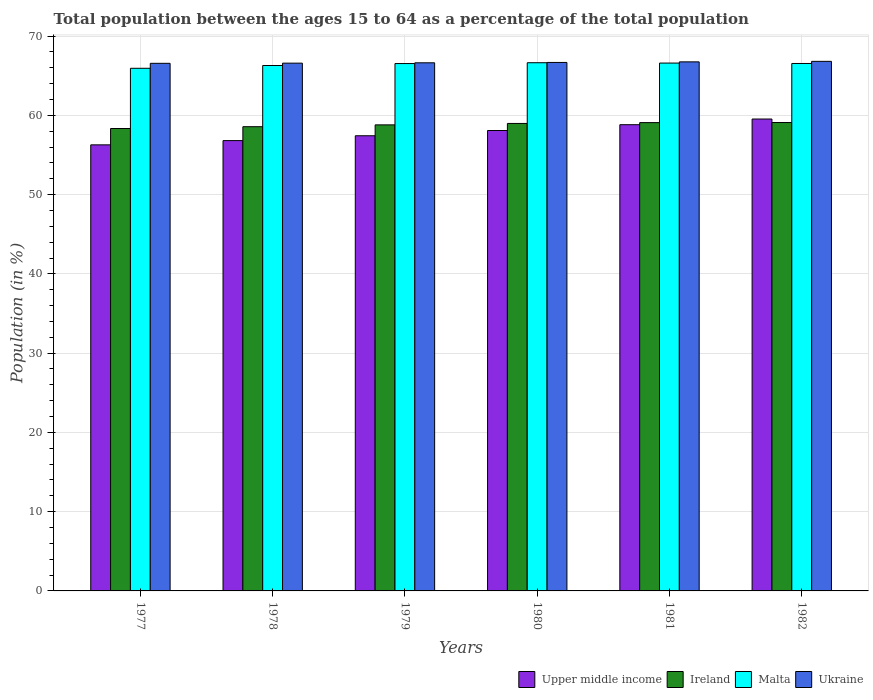What is the percentage of the population ages 15 to 64 in Malta in 1980?
Provide a short and direct response. 66.64. Across all years, what is the maximum percentage of the population ages 15 to 64 in Malta?
Your answer should be very brief. 66.64. Across all years, what is the minimum percentage of the population ages 15 to 64 in Ukraine?
Offer a terse response. 66.57. In which year was the percentage of the population ages 15 to 64 in Ireland maximum?
Offer a very short reply. 1982. In which year was the percentage of the population ages 15 to 64 in Upper middle income minimum?
Provide a short and direct response. 1977. What is the total percentage of the population ages 15 to 64 in Malta in the graph?
Your answer should be very brief. 398.56. What is the difference between the percentage of the population ages 15 to 64 in Malta in 1979 and that in 1982?
Make the answer very short. -0.01. What is the difference between the percentage of the population ages 15 to 64 in Malta in 1977 and the percentage of the population ages 15 to 64 in Upper middle income in 1978?
Offer a terse response. 9.12. What is the average percentage of the population ages 15 to 64 in Ireland per year?
Provide a succinct answer. 58.81. In the year 1981, what is the difference between the percentage of the population ages 15 to 64 in Malta and percentage of the population ages 15 to 64 in Ireland?
Provide a succinct answer. 7.51. In how many years, is the percentage of the population ages 15 to 64 in Ireland greater than 46?
Provide a short and direct response. 6. What is the ratio of the percentage of the population ages 15 to 64 in Ukraine in 1977 to that in 1979?
Keep it short and to the point. 1. Is the difference between the percentage of the population ages 15 to 64 in Malta in 1980 and 1981 greater than the difference between the percentage of the population ages 15 to 64 in Ireland in 1980 and 1981?
Give a very brief answer. Yes. What is the difference between the highest and the second highest percentage of the population ages 15 to 64 in Upper middle income?
Provide a succinct answer. 0.71. What is the difference between the highest and the lowest percentage of the population ages 15 to 64 in Upper middle income?
Offer a terse response. 3.26. Is the sum of the percentage of the population ages 15 to 64 in Upper middle income in 1978 and 1979 greater than the maximum percentage of the population ages 15 to 64 in Malta across all years?
Ensure brevity in your answer.  Yes. What does the 3rd bar from the left in 1979 represents?
Your response must be concise. Malta. What does the 4th bar from the right in 1982 represents?
Your response must be concise. Upper middle income. How many bars are there?
Your answer should be very brief. 24. How many years are there in the graph?
Ensure brevity in your answer.  6. What is the difference between two consecutive major ticks on the Y-axis?
Keep it short and to the point. 10. Are the values on the major ticks of Y-axis written in scientific E-notation?
Make the answer very short. No. Does the graph contain any zero values?
Keep it short and to the point. No. Where does the legend appear in the graph?
Your response must be concise. Bottom right. How are the legend labels stacked?
Ensure brevity in your answer.  Horizontal. What is the title of the graph?
Offer a very short reply. Total population between the ages 15 to 64 as a percentage of the total population. What is the label or title of the X-axis?
Your answer should be very brief. Years. What is the label or title of the Y-axis?
Your answer should be very brief. Population (in %). What is the Population (in %) in Upper middle income in 1977?
Offer a terse response. 56.28. What is the Population (in %) in Ireland in 1977?
Provide a short and direct response. 58.34. What is the Population (in %) of Malta in 1977?
Your answer should be compact. 65.94. What is the Population (in %) of Ukraine in 1977?
Offer a terse response. 66.57. What is the Population (in %) of Upper middle income in 1978?
Provide a short and direct response. 56.82. What is the Population (in %) in Ireland in 1978?
Make the answer very short. 58.57. What is the Population (in %) in Malta in 1978?
Your answer should be compact. 66.29. What is the Population (in %) of Ukraine in 1978?
Make the answer very short. 66.59. What is the Population (in %) of Upper middle income in 1979?
Give a very brief answer. 57.43. What is the Population (in %) of Ireland in 1979?
Your answer should be very brief. 58.8. What is the Population (in %) in Malta in 1979?
Give a very brief answer. 66.54. What is the Population (in %) of Ukraine in 1979?
Ensure brevity in your answer.  66.63. What is the Population (in %) in Upper middle income in 1980?
Give a very brief answer. 58.09. What is the Population (in %) in Ireland in 1980?
Your answer should be compact. 58.98. What is the Population (in %) of Malta in 1980?
Give a very brief answer. 66.64. What is the Population (in %) in Ukraine in 1980?
Give a very brief answer. 66.68. What is the Population (in %) of Upper middle income in 1981?
Give a very brief answer. 58.82. What is the Population (in %) of Ireland in 1981?
Offer a very short reply. 59.09. What is the Population (in %) in Malta in 1981?
Ensure brevity in your answer.  66.6. What is the Population (in %) in Ukraine in 1981?
Your response must be concise. 66.75. What is the Population (in %) in Upper middle income in 1982?
Your answer should be compact. 59.54. What is the Population (in %) of Ireland in 1982?
Provide a succinct answer. 59.1. What is the Population (in %) of Malta in 1982?
Offer a very short reply. 66.55. What is the Population (in %) in Ukraine in 1982?
Ensure brevity in your answer.  66.82. Across all years, what is the maximum Population (in %) in Upper middle income?
Give a very brief answer. 59.54. Across all years, what is the maximum Population (in %) in Ireland?
Provide a short and direct response. 59.1. Across all years, what is the maximum Population (in %) of Malta?
Offer a very short reply. 66.64. Across all years, what is the maximum Population (in %) of Ukraine?
Ensure brevity in your answer.  66.82. Across all years, what is the minimum Population (in %) in Upper middle income?
Provide a succinct answer. 56.28. Across all years, what is the minimum Population (in %) of Ireland?
Ensure brevity in your answer.  58.34. Across all years, what is the minimum Population (in %) in Malta?
Your response must be concise. 65.94. Across all years, what is the minimum Population (in %) of Ukraine?
Give a very brief answer. 66.57. What is the total Population (in %) of Upper middle income in the graph?
Make the answer very short. 346.98. What is the total Population (in %) in Ireland in the graph?
Give a very brief answer. 352.88. What is the total Population (in %) of Malta in the graph?
Offer a terse response. 398.56. What is the total Population (in %) in Ukraine in the graph?
Provide a short and direct response. 400.03. What is the difference between the Population (in %) of Upper middle income in 1977 and that in 1978?
Provide a short and direct response. -0.54. What is the difference between the Population (in %) in Ireland in 1977 and that in 1978?
Ensure brevity in your answer.  -0.23. What is the difference between the Population (in %) in Malta in 1977 and that in 1978?
Offer a very short reply. -0.35. What is the difference between the Population (in %) in Ukraine in 1977 and that in 1978?
Provide a short and direct response. -0.02. What is the difference between the Population (in %) in Upper middle income in 1977 and that in 1979?
Your answer should be compact. -1.15. What is the difference between the Population (in %) in Ireland in 1977 and that in 1979?
Offer a very short reply. -0.46. What is the difference between the Population (in %) of Malta in 1977 and that in 1979?
Your answer should be compact. -0.6. What is the difference between the Population (in %) of Ukraine in 1977 and that in 1979?
Provide a succinct answer. -0.06. What is the difference between the Population (in %) of Upper middle income in 1977 and that in 1980?
Give a very brief answer. -1.81. What is the difference between the Population (in %) in Ireland in 1977 and that in 1980?
Your answer should be compact. -0.64. What is the difference between the Population (in %) of Malta in 1977 and that in 1980?
Ensure brevity in your answer.  -0.7. What is the difference between the Population (in %) in Ukraine in 1977 and that in 1980?
Ensure brevity in your answer.  -0.11. What is the difference between the Population (in %) in Upper middle income in 1977 and that in 1981?
Make the answer very short. -2.54. What is the difference between the Population (in %) in Ireland in 1977 and that in 1981?
Provide a succinct answer. -0.74. What is the difference between the Population (in %) of Malta in 1977 and that in 1981?
Keep it short and to the point. -0.66. What is the difference between the Population (in %) of Ukraine in 1977 and that in 1981?
Provide a short and direct response. -0.18. What is the difference between the Population (in %) of Upper middle income in 1977 and that in 1982?
Give a very brief answer. -3.26. What is the difference between the Population (in %) of Ireland in 1977 and that in 1982?
Keep it short and to the point. -0.76. What is the difference between the Population (in %) of Malta in 1977 and that in 1982?
Your answer should be very brief. -0.61. What is the difference between the Population (in %) in Ukraine in 1977 and that in 1982?
Make the answer very short. -0.25. What is the difference between the Population (in %) in Upper middle income in 1978 and that in 1979?
Give a very brief answer. -0.61. What is the difference between the Population (in %) of Ireland in 1978 and that in 1979?
Offer a terse response. -0.23. What is the difference between the Population (in %) of Malta in 1978 and that in 1979?
Keep it short and to the point. -0.25. What is the difference between the Population (in %) of Ukraine in 1978 and that in 1979?
Offer a terse response. -0.04. What is the difference between the Population (in %) of Upper middle income in 1978 and that in 1980?
Your response must be concise. -1.27. What is the difference between the Population (in %) of Ireland in 1978 and that in 1980?
Your answer should be compact. -0.41. What is the difference between the Population (in %) of Malta in 1978 and that in 1980?
Your response must be concise. -0.35. What is the difference between the Population (in %) in Ukraine in 1978 and that in 1980?
Provide a short and direct response. -0.09. What is the difference between the Population (in %) of Upper middle income in 1978 and that in 1981?
Your answer should be very brief. -2.01. What is the difference between the Population (in %) in Ireland in 1978 and that in 1981?
Make the answer very short. -0.51. What is the difference between the Population (in %) in Malta in 1978 and that in 1981?
Offer a very short reply. -0.31. What is the difference between the Population (in %) of Ukraine in 1978 and that in 1981?
Ensure brevity in your answer.  -0.16. What is the difference between the Population (in %) in Upper middle income in 1978 and that in 1982?
Make the answer very short. -2.72. What is the difference between the Population (in %) in Ireland in 1978 and that in 1982?
Offer a very short reply. -0.53. What is the difference between the Population (in %) of Malta in 1978 and that in 1982?
Offer a very short reply. -0.26. What is the difference between the Population (in %) in Ukraine in 1978 and that in 1982?
Provide a short and direct response. -0.23. What is the difference between the Population (in %) of Upper middle income in 1979 and that in 1980?
Make the answer very short. -0.66. What is the difference between the Population (in %) in Ireland in 1979 and that in 1980?
Keep it short and to the point. -0.18. What is the difference between the Population (in %) in Malta in 1979 and that in 1980?
Keep it short and to the point. -0.1. What is the difference between the Population (in %) of Ukraine in 1979 and that in 1980?
Your answer should be compact. -0.04. What is the difference between the Population (in %) in Upper middle income in 1979 and that in 1981?
Give a very brief answer. -1.4. What is the difference between the Population (in %) in Ireland in 1979 and that in 1981?
Keep it short and to the point. -0.28. What is the difference between the Population (in %) of Malta in 1979 and that in 1981?
Make the answer very short. -0.06. What is the difference between the Population (in %) of Ukraine in 1979 and that in 1981?
Your answer should be very brief. -0.12. What is the difference between the Population (in %) of Upper middle income in 1979 and that in 1982?
Your answer should be very brief. -2.11. What is the difference between the Population (in %) of Ireland in 1979 and that in 1982?
Keep it short and to the point. -0.29. What is the difference between the Population (in %) in Malta in 1979 and that in 1982?
Offer a very short reply. -0.01. What is the difference between the Population (in %) of Ukraine in 1979 and that in 1982?
Make the answer very short. -0.18. What is the difference between the Population (in %) in Upper middle income in 1980 and that in 1981?
Make the answer very short. -0.73. What is the difference between the Population (in %) in Ireland in 1980 and that in 1981?
Your response must be concise. -0.1. What is the difference between the Population (in %) of Malta in 1980 and that in 1981?
Provide a short and direct response. 0.04. What is the difference between the Population (in %) in Ukraine in 1980 and that in 1981?
Make the answer very short. -0.07. What is the difference between the Population (in %) in Upper middle income in 1980 and that in 1982?
Your answer should be very brief. -1.45. What is the difference between the Population (in %) in Ireland in 1980 and that in 1982?
Provide a succinct answer. -0.11. What is the difference between the Population (in %) of Malta in 1980 and that in 1982?
Give a very brief answer. 0.1. What is the difference between the Population (in %) in Ukraine in 1980 and that in 1982?
Keep it short and to the point. -0.14. What is the difference between the Population (in %) of Upper middle income in 1981 and that in 1982?
Make the answer very short. -0.71. What is the difference between the Population (in %) of Ireland in 1981 and that in 1982?
Offer a terse response. -0.01. What is the difference between the Population (in %) in Malta in 1981 and that in 1982?
Keep it short and to the point. 0.05. What is the difference between the Population (in %) of Ukraine in 1981 and that in 1982?
Your answer should be compact. -0.06. What is the difference between the Population (in %) in Upper middle income in 1977 and the Population (in %) in Ireland in 1978?
Offer a terse response. -2.29. What is the difference between the Population (in %) in Upper middle income in 1977 and the Population (in %) in Malta in 1978?
Make the answer very short. -10.01. What is the difference between the Population (in %) of Upper middle income in 1977 and the Population (in %) of Ukraine in 1978?
Your response must be concise. -10.31. What is the difference between the Population (in %) in Ireland in 1977 and the Population (in %) in Malta in 1978?
Give a very brief answer. -7.95. What is the difference between the Population (in %) in Ireland in 1977 and the Population (in %) in Ukraine in 1978?
Offer a very short reply. -8.25. What is the difference between the Population (in %) of Malta in 1977 and the Population (in %) of Ukraine in 1978?
Make the answer very short. -0.65. What is the difference between the Population (in %) of Upper middle income in 1977 and the Population (in %) of Ireland in 1979?
Ensure brevity in your answer.  -2.52. What is the difference between the Population (in %) of Upper middle income in 1977 and the Population (in %) of Malta in 1979?
Provide a short and direct response. -10.26. What is the difference between the Population (in %) in Upper middle income in 1977 and the Population (in %) in Ukraine in 1979?
Offer a terse response. -10.35. What is the difference between the Population (in %) in Ireland in 1977 and the Population (in %) in Malta in 1979?
Provide a succinct answer. -8.2. What is the difference between the Population (in %) in Ireland in 1977 and the Population (in %) in Ukraine in 1979?
Ensure brevity in your answer.  -8.29. What is the difference between the Population (in %) in Malta in 1977 and the Population (in %) in Ukraine in 1979?
Your answer should be compact. -0.69. What is the difference between the Population (in %) of Upper middle income in 1977 and the Population (in %) of Ireland in 1980?
Provide a short and direct response. -2.7. What is the difference between the Population (in %) of Upper middle income in 1977 and the Population (in %) of Malta in 1980?
Provide a short and direct response. -10.36. What is the difference between the Population (in %) in Upper middle income in 1977 and the Population (in %) in Ukraine in 1980?
Offer a very short reply. -10.4. What is the difference between the Population (in %) in Ireland in 1977 and the Population (in %) in Malta in 1980?
Ensure brevity in your answer.  -8.3. What is the difference between the Population (in %) in Ireland in 1977 and the Population (in %) in Ukraine in 1980?
Your answer should be compact. -8.33. What is the difference between the Population (in %) in Malta in 1977 and the Population (in %) in Ukraine in 1980?
Provide a succinct answer. -0.74. What is the difference between the Population (in %) in Upper middle income in 1977 and the Population (in %) in Ireland in 1981?
Keep it short and to the point. -2.8. What is the difference between the Population (in %) in Upper middle income in 1977 and the Population (in %) in Malta in 1981?
Keep it short and to the point. -10.32. What is the difference between the Population (in %) in Upper middle income in 1977 and the Population (in %) in Ukraine in 1981?
Ensure brevity in your answer.  -10.47. What is the difference between the Population (in %) in Ireland in 1977 and the Population (in %) in Malta in 1981?
Provide a succinct answer. -8.26. What is the difference between the Population (in %) of Ireland in 1977 and the Population (in %) of Ukraine in 1981?
Your response must be concise. -8.41. What is the difference between the Population (in %) in Malta in 1977 and the Population (in %) in Ukraine in 1981?
Provide a short and direct response. -0.81. What is the difference between the Population (in %) in Upper middle income in 1977 and the Population (in %) in Ireland in 1982?
Ensure brevity in your answer.  -2.82. What is the difference between the Population (in %) in Upper middle income in 1977 and the Population (in %) in Malta in 1982?
Your answer should be compact. -10.27. What is the difference between the Population (in %) in Upper middle income in 1977 and the Population (in %) in Ukraine in 1982?
Your answer should be compact. -10.53. What is the difference between the Population (in %) in Ireland in 1977 and the Population (in %) in Malta in 1982?
Make the answer very short. -8.21. What is the difference between the Population (in %) in Ireland in 1977 and the Population (in %) in Ukraine in 1982?
Your response must be concise. -8.47. What is the difference between the Population (in %) of Malta in 1977 and the Population (in %) of Ukraine in 1982?
Make the answer very short. -0.88. What is the difference between the Population (in %) in Upper middle income in 1978 and the Population (in %) in Ireland in 1979?
Your answer should be compact. -1.99. What is the difference between the Population (in %) in Upper middle income in 1978 and the Population (in %) in Malta in 1979?
Provide a succinct answer. -9.72. What is the difference between the Population (in %) in Upper middle income in 1978 and the Population (in %) in Ukraine in 1979?
Provide a short and direct response. -9.82. What is the difference between the Population (in %) in Ireland in 1978 and the Population (in %) in Malta in 1979?
Offer a terse response. -7.97. What is the difference between the Population (in %) in Ireland in 1978 and the Population (in %) in Ukraine in 1979?
Ensure brevity in your answer.  -8.06. What is the difference between the Population (in %) of Malta in 1978 and the Population (in %) of Ukraine in 1979?
Your answer should be compact. -0.34. What is the difference between the Population (in %) of Upper middle income in 1978 and the Population (in %) of Ireland in 1980?
Your response must be concise. -2.16. What is the difference between the Population (in %) of Upper middle income in 1978 and the Population (in %) of Malta in 1980?
Give a very brief answer. -9.83. What is the difference between the Population (in %) of Upper middle income in 1978 and the Population (in %) of Ukraine in 1980?
Your response must be concise. -9.86. What is the difference between the Population (in %) in Ireland in 1978 and the Population (in %) in Malta in 1980?
Your answer should be compact. -8.07. What is the difference between the Population (in %) of Ireland in 1978 and the Population (in %) of Ukraine in 1980?
Ensure brevity in your answer.  -8.11. What is the difference between the Population (in %) of Malta in 1978 and the Population (in %) of Ukraine in 1980?
Ensure brevity in your answer.  -0.39. What is the difference between the Population (in %) in Upper middle income in 1978 and the Population (in %) in Ireland in 1981?
Your answer should be very brief. -2.27. What is the difference between the Population (in %) of Upper middle income in 1978 and the Population (in %) of Malta in 1981?
Give a very brief answer. -9.78. What is the difference between the Population (in %) in Upper middle income in 1978 and the Population (in %) in Ukraine in 1981?
Give a very brief answer. -9.93. What is the difference between the Population (in %) in Ireland in 1978 and the Population (in %) in Malta in 1981?
Offer a very short reply. -8.03. What is the difference between the Population (in %) in Ireland in 1978 and the Population (in %) in Ukraine in 1981?
Offer a very short reply. -8.18. What is the difference between the Population (in %) in Malta in 1978 and the Population (in %) in Ukraine in 1981?
Offer a very short reply. -0.46. What is the difference between the Population (in %) in Upper middle income in 1978 and the Population (in %) in Ireland in 1982?
Your answer should be compact. -2.28. What is the difference between the Population (in %) of Upper middle income in 1978 and the Population (in %) of Malta in 1982?
Your answer should be very brief. -9.73. What is the difference between the Population (in %) of Upper middle income in 1978 and the Population (in %) of Ukraine in 1982?
Provide a succinct answer. -10. What is the difference between the Population (in %) in Ireland in 1978 and the Population (in %) in Malta in 1982?
Ensure brevity in your answer.  -7.98. What is the difference between the Population (in %) of Ireland in 1978 and the Population (in %) of Ukraine in 1982?
Your answer should be very brief. -8.24. What is the difference between the Population (in %) in Malta in 1978 and the Population (in %) in Ukraine in 1982?
Offer a terse response. -0.52. What is the difference between the Population (in %) of Upper middle income in 1979 and the Population (in %) of Ireland in 1980?
Make the answer very short. -1.55. What is the difference between the Population (in %) of Upper middle income in 1979 and the Population (in %) of Malta in 1980?
Ensure brevity in your answer.  -9.21. What is the difference between the Population (in %) of Upper middle income in 1979 and the Population (in %) of Ukraine in 1980?
Your answer should be compact. -9.25. What is the difference between the Population (in %) of Ireland in 1979 and the Population (in %) of Malta in 1980?
Your response must be concise. -7.84. What is the difference between the Population (in %) of Ireland in 1979 and the Population (in %) of Ukraine in 1980?
Provide a succinct answer. -7.87. What is the difference between the Population (in %) of Malta in 1979 and the Population (in %) of Ukraine in 1980?
Give a very brief answer. -0.14. What is the difference between the Population (in %) of Upper middle income in 1979 and the Population (in %) of Ireland in 1981?
Make the answer very short. -1.66. What is the difference between the Population (in %) in Upper middle income in 1979 and the Population (in %) in Malta in 1981?
Keep it short and to the point. -9.17. What is the difference between the Population (in %) in Upper middle income in 1979 and the Population (in %) in Ukraine in 1981?
Give a very brief answer. -9.32. What is the difference between the Population (in %) in Ireland in 1979 and the Population (in %) in Malta in 1981?
Your response must be concise. -7.8. What is the difference between the Population (in %) in Ireland in 1979 and the Population (in %) in Ukraine in 1981?
Provide a short and direct response. -7.95. What is the difference between the Population (in %) of Malta in 1979 and the Population (in %) of Ukraine in 1981?
Your answer should be compact. -0.21. What is the difference between the Population (in %) of Upper middle income in 1979 and the Population (in %) of Ireland in 1982?
Ensure brevity in your answer.  -1.67. What is the difference between the Population (in %) in Upper middle income in 1979 and the Population (in %) in Malta in 1982?
Your response must be concise. -9.12. What is the difference between the Population (in %) of Upper middle income in 1979 and the Population (in %) of Ukraine in 1982?
Provide a succinct answer. -9.39. What is the difference between the Population (in %) of Ireland in 1979 and the Population (in %) of Malta in 1982?
Ensure brevity in your answer.  -7.75. What is the difference between the Population (in %) in Ireland in 1979 and the Population (in %) in Ukraine in 1982?
Your answer should be compact. -8.01. What is the difference between the Population (in %) of Malta in 1979 and the Population (in %) of Ukraine in 1982?
Provide a short and direct response. -0.28. What is the difference between the Population (in %) in Upper middle income in 1980 and the Population (in %) in Ireland in 1981?
Your response must be concise. -0.99. What is the difference between the Population (in %) in Upper middle income in 1980 and the Population (in %) in Malta in 1981?
Your response must be concise. -8.51. What is the difference between the Population (in %) of Upper middle income in 1980 and the Population (in %) of Ukraine in 1981?
Your answer should be compact. -8.66. What is the difference between the Population (in %) of Ireland in 1980 and the Population (in %) of Malta in 1981?
Ensure brevity in your answer.  -7.62. What is the difference between the Population (in %) in Ireland in 1980 and the Population (in %) in Ukraine in 1981?
Keep it short and to the point. -7.77. What is the difference between the Population (in %) of Malta in 1980 and the Population (in %) of Ukraine in 1981?
Give a very brief answer. -0.11. What is the difference between the Population (in %) in Upper middle income in 1980 and the Population (in %) in Ireland in 1982?
Give a very brief answer. -1.01. What is the difference between the Population (in %) in Upper middle income in 1980 and the Population (in %) in Malta in 1982?
Your answer should be compact. -8.46. What is the difference between the Population (in %) in Upper middle income in 1980 and the Population (in %) in Ukraine in 1982?
Offer a very short reply. -8.72. What is the difference between the Population (in %) in Ireland in 1980 and the Population (in %) in Malta in 1982?
Ensure brevity in your answer.  -7.57. What is the difference between the Population (in %) in Ireland in 1980 and the Population (in %) in Ukraine in 1982?
Give a very brief answer. -7.83. What is the difference between the Population (in %) of Malta in 1980 and the Population (in %) of Ukraine in 1982?
Your response must be concise. -0.17. What is the difference between the Population (in %) of Upper middle income in 1981 and the Population (in %) of Ireland in 1982?
Your answer should be very brief. -0.27. What is the difference between the Population (in %) in Upper middle income in 1981 and the Population (in %) in Malta in 1982?
Offer a terse response. -7.72. What is the difference between the Population (in %) of Upper middle income in 1981 and the Population (in %) of Ukraine in 1982?
Keep it short and to the point. -7.99. What is the difference between the Population (in %) in Ireland in 1981 and the Population (in %) in Malta in 1982?
Your answer should be very brief. -7.46. What is the difference between the Population (in %) of Ireland in 1981 and the Population (in %) of Ukraine in 1982?
Ensure brevity in your answer.  -7.73. What is the difference between the Population (in %) in Malta in 1981 and the Population (in %) in Ukraine in 1982?
Give a very brief answer. -0.22. What is the average Population (in %) of Upper middle income per year?
Offer a very short reply. 57.83. What is the average Population (in %) in Ireland per year?
Provide a succinct answer. 58.81. What is the average Population (in %) of Malta per year?
Give a very brief answer. 66.43. What is the average Population (in %) of Ukraine per year?
Ensure brevity in your answer.  66.67. In the year 1977, what is the difference between the Population (in %) of Upper middle income and Population (in %) of Ireland?
Offer a very short reply. -2.06. In the year 1977, what is the difference between the Population (in %) of Upper middle income and Population (in %) of Malta?
Offer a very short reply. -9.66. In the year 1977, what is the difference between the Population (in %) in Upper middle income and Population (in %) in Ukraine?
Offer a terse response. -10.29. In the year 1977, what is the difference between the Population (in %) of Ireland and Population (in %) of Malta?
Your answer should be compact. -7.6. In the year 1977, what is the difference between the Population (in %) of Ireland and Population (in %) of Ukraine?
Offer a very short reply. -8.23. In the year 1977, what is the difference between the Population (in %) of Malta and Population (in %) of Ukraine?
Your answer should be very brief. -0.63. In the year 1978, what is the difference between the Population (in %) of Upper middle income and Population (in %) of Ireland?
Your answer should be compact. -1.75. In the year 1978, what is the difference between the Population (in %) of Upper middle income and Population (in %) of Malta?
Provide a short and direct response. -9.47. In the year 1978, what is the difference between the Population (in %) of Upper middle income and Population (in %) of Ukraine?
Make the answer very short. -9.77. In the year 1978, what is the difference between the Population (in %) in Ireland and Population (in %) in Malta?
Offer a terse response. -7.72. In the year 1978, what is the difference between the Population (in %) of Ireland and Population (in %) of Ukraine?
Keep it short and to the point. -8.02. In the year 1978, what is the difference between the Population (in %) of Malta and Population (in %) of Ukraine?
Offer a terse response. -0.3. In the year 1979, what is the difference between the Population (in %) in Upper middle income and Population (in %) in Ireland?
Make the answer very short. -1.37. In the year 1979, what is the difference between the Population (in %) in Upper middle income and Population (in %) in Malta?
Your answer should be compact. -9.11. In the year 1979, what is the difference between the Population (in %) in Upper middle income and Population (in %) in Ukraine?
Give a very brief answer. -9.2. In the year 1979, what is the difference between the Population (in %) in Ireland and Population (in %) in Malta?
Give a very brief answer. -7.74. In the year 1979, what is the difference between the Population (in %) in Ireland and Population (in %) in Ukraine?
Make the answer very short. -7.83. In the year 1979, what is the difference between the Population (in %) of Malta and Population (in %) of Ukraine?
Provide a short and direct response. -0.09. In the year 1980, what is the difference between the Population (in %) of Upper middle income and Population (in %) of Ireland?
Offer a terse response. -0.89. In the year 1980, what is the difference between the Population (in %) of Upper middle income and Population (in %) of Malta?
Keep it short and to the point. -8.55. In the year 1980, what is the difference between the Population (in %) of Upper middle income and Population (in %) of Ukraine?
Ensure brevity in your answer.  -8.59. In the year 1980, what is the difference between the Population (in %) in Ireland and Population (in %) in Malta?
Offer a terse response. -7.66. In the year 1980, what is the difference between the Population (in %) of Ireland and Population (in %) of Ukraine?
Offer a very short reply. -7.69. In the year 1980, what is the difference between the Population (in %) of Malta and Population (in %) of Ukraine?
Keep it short and to the point. -0.03. In the year 1981, what is the difference between the Population (in %) in Upper middle income and Population (in %) in Ireland?
Keep it short and to the point. -0.26. In the year 1981, what is the difference between the Population (in %) in Upper middle income and Population (in %) in Malta?
Ensure brevity in your answer.  -7.77. In the year 1981, what is the difference between the Population (in %) of Upper middle income and Population (in %) of Ukraine?
Offer a very short reply. -7.93. In the year 1981, what is the difference between the Population (in %) of Ireland and Population (in %) of Malta?
Your answer should be very brief. -7.51. In the year 1981, what is the difference between the Population (in %) in Ireland and Population (in %) in Ukraine?
Offer a very short reply. -7.67. In the year 1981, what is the difference between the Population (in %) in Malta and Population (in %) in Ukraine?
Make the answer very short. -0.15. In the year 1982, what is the difference between the Population (in %) of Upper middle income and Population (in %) of Ireland?
Give a very brief answer. 0.44. In the year 1982, what is the difference between the Population (in %) of Upper middle income and Population (in %) of Malta?
Offer a very short reply. -7.01. In the year 1982, what is the difference between the Population (in %) of Upper middle income and Population (in %) of Ukraine?
Keep it short and to the point. -7.28. In the year 1982, what is the difference between the Population (in %) of Ireland and Population (in %) of Malta?
Keep it short and to the point. -7.45. In the year 1982, what is the difference between the Population (in %) of Ireland and Population (in %) of Ukraine?
Offer a terse response. -7.72. In the year 1982, what is the difference between the Population (in %) in Malta and Population (in %) in Ukraine?
Your answer should be very brief. -0.27. What is the ratio of the Population (in %) in Upper middle income in 1977 to that in 1978?
Keep it short and to the point. 0.99. What is the ratio of the Population (in %) in Ireland in 1977 to that in 1978?
Your answer should be very brief. 1. What is the ratio of the Population (in %) in Ukraine in 1977 to that in 1978?
Offer a terse response. 1. What is the ratio of the Population (in %) of Upper middle income in 1977 to that in 1979?
Keep it short and to the point. 0.98. What is the ratio of the Population (in %) of Ireland in 1977 to that in 1979?
Provide a succinct answer. 0.99. What is the ratio of the Population (in %) in Upper middle income in 1977 to that in 1980?
Make the answer very short. 0.97. What is the ratio of the Population (in %) of Ukraine in 1977 to that in 1980?
Your answer should be very brief. 1. What is the ratio of the Population (in %) in Upper middle income in 1977 to that in 1981?
Offer a very short reply. 0.96. What is the ratio of the Population (in %) in Ireland in 1977 to that in 1981?
Provide a succinct answer. 0.99. What is the ratio of the Population (in %) of Malta in 1977 to that in 1981?
Ensure brevity in your answer.  0.99. What is the ratio of the Population (in %) in Upper middle income in 1977 to that in 1982?
Offer a very short reply. 0.95. What is the ratio of the Population (in %) in Ireland in 1977 to that in 1982?
Your answer should be very brief. 0.99. What is the ratio of the Population (in %) in Malta in 1977 to that in 1982?
Keep it short and to the point. 0.99. What is the ratio of the Population (in %) of Upper middle income in 1978 to that in 1979?
Keep it short and to the point. 0.99. What is the ratio of the Population (in %) of Ireland in 1978 to that in 1979?
Make the answer very short. 1. What is the ratio of the Population (in %) of Ukraine in 1978 to that in 1979?
Your response must be concise. 1. What is the ratio of the Population (in %) in Upper middle income in 1978 to that in 1980?
Provide a short and direct response. 0.98. What is the ratio of the Population (in %) in Upper middle income in 1978 to that in 1981?
Make the answer very short. 0.97. What is the ratio of the Population (in %) of Malta in 1978 to that in 1981?
Keep it short and to the point. 1. What is the ratio of the Population (in %) of Upper middle income in 1978 to that in 1982?
Keep it short and to the point. 0.95. What is the ratio of the Population (in %) in Ireland in 1978 to that in 1982?
Give a very brief answer. 0.99. What is the ratio of the Population (in %) in Malta in 1978 to that in 1982?
Ensure brevity in your answer.  1. What is the ratio of the Population (in %) in Upper middle income in 1979 to that in 1980?
Offer a very short reply. 0.99. What is the ratio of the Population (in %) in Malta in 1979 to that in 1980?
Provide a short and direct response. 1. What is the ratio of the Population (in %) in Ukraine in 1979 to that in 1980?
Provide a succinct answer. 1. What is the ratio of the Population (in %) of Upper middle income in 1979 to that in 1981?
Offer a very short reply. 0.98. What is the ratio of the Population (in %) of Upper middle income in 1979 to that in 1982?
Your answer should be compact. 0.96. What is the ratio of the Population (in %) in Ireland in 1979 to that in 1982?
Provide a succinct answer. 0.99. What is the ratio of the Population (in %) of Malta in 1979 to that in 1982?
Ensure brevity in your answer.  1. What is the ratio of the Population (in %) of Upper middle income in 1980 to that in 1981?
Offer a very short reply. 0.99. What is the ratio of the Population (in %) of Malta in 1980 to that in 1981?
Offer a terse response. 1. What is the ratio of the Population (in %) of Ukraine in 1980 to that in 1981?
Keep it short and to the point. 1. What is the ratio of the Population (in %) of Upper middle income in 1980 to that in 1982?
Keep it short and to the point. 0.98. What is the ratio of the Population (in %) in Malta in 1980 to that in 1982?
Your response must be concise. 1. What is the ratio of the Population (in %) of Ireland in 1981 to that in 1982?
Provide a succinct answer. 1. What is the ratio of the Population (in %) of Ukraine in 1981 to that in 1982?
Your answer should be very brief. 1. What is the difference between the highest and the second highest Population (in %) in Upper middle income?
Provide a succinct answer. 0.71. What is the difference between the highest and the second highest Population (in %) in Ireland?
Give a very brief answer. 0.01. What is the difference between the highest and the second highest Population (in %) in Malta?
Provide a succinct answer. 0.04. What is the difference between the highest and the second highest Population (in %) of Ukraine?
Offer a very short reply. 0.06. What is the difference between the highest and the lowest Population (in %) of Upper middle income?
Give a very brief answer. 3.26. What is the difference between the highest and the lowest Population (in %) of Ireland?
Your answer should be very brief. 0.76. What is the difference between the highest and the lowest Population (in %) in Malta?
Provide a succinct answer. 0.7. What is the difference between the highest and the lowest Population (in %) of Ukraine?
Your response must be concise. 0.25. 